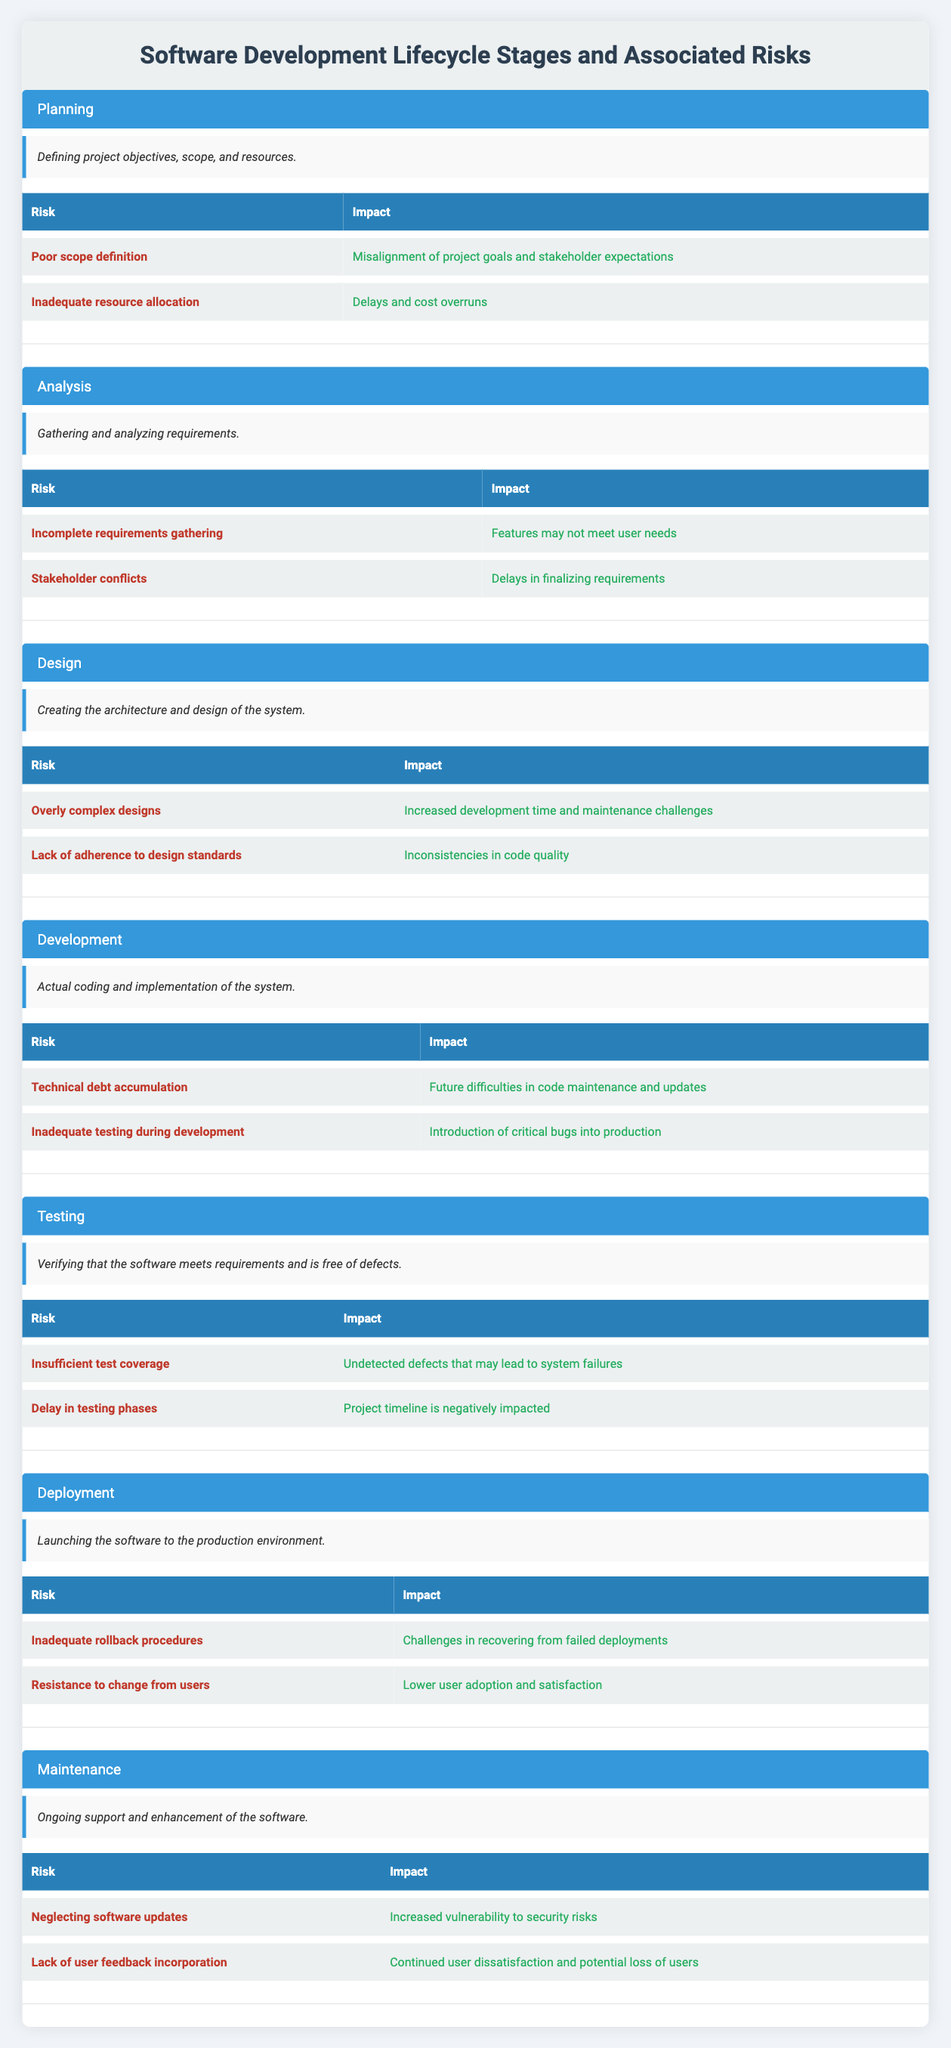What are the risks associated with the Planning stage? There are two risks listed under the Planning stage: "Poor scope definition" and "Inadequate resource allocation."
Answer: Poor scope definition, Inadequate resource allocation Is "Incomplete requirements gathering" a risk in the Testing stage? No, "Incomplete requirements gathering" is listed under the Analysis stage, not the Testing stage.
Answer: No Which stage has the risk of "Technical debt accumulation"? The risk "Technical debt accumulation" is associated with the Development stage.
Answer: Development What is the combined impact of the risks in the Maintenance stage? The impacts of the risks in the Maintenance stage are "Increased vulnerability to security risks" and "Continued user dissatisfaction and potential loss of users." Summing these impacts in terms of severity might not be mathematically quantifiable, but collectively they indicate significant potential drawbacks.
Answer: Significant potential drawbacks Which stage is associated with the risk of "Resistance to change from users"? The risk of "Resistance to change from users" is associated with the Deployment stage.
Answer: Deployment Are there more risks listed under the Development stage or the Design stage? The Development stage lists two risks ("Technical debt accumulation" and "Inadequate testing during development") while the Design stage also lists two risks ("Overly complex designs" and "Lack of adherence to design standards"). Therefore, they have equal numbers of risks listed.
Answer: Equal numbers What is the impact of "Delayed testing phases"? The impact of "Delay in testing phases" is that it negatively impacts the project timeline.
Answer: Negatively impacts the project timeline What is the lack of user feedback incorporation associated with in terms of risk? The lack of user feedback incorporation is associated with the risk of continued user dissatisfaction and potential loss of users in the Maintenance stage.
Answer: Continued user dissatisfaction and potential loss of users 